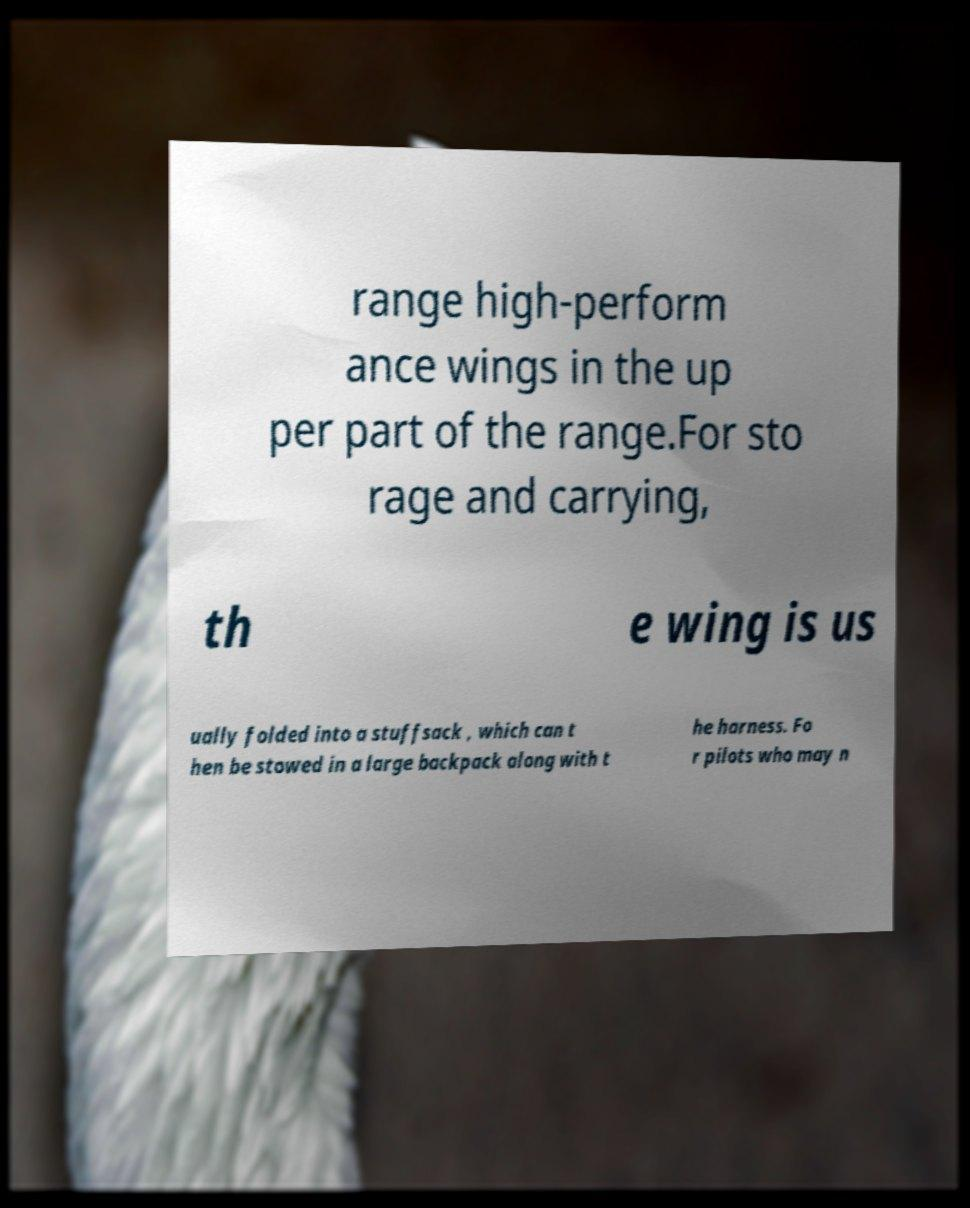There's text embedded in this image that I need extracted. Can you transcribe it verbatim? range high-perform ance wings in the up per part of the range.For sto rage and carrying, th e wing is us ually folded into a stuffsack , which can t hen be stowed in a large backpack along with t he harness. Fo r pilots who may n 